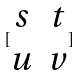<formula> <loc_0><loc_0><loc_500><loc_500>[ \begin{matrix} s & t \\ u & v \end{matrix} ]</formula> 